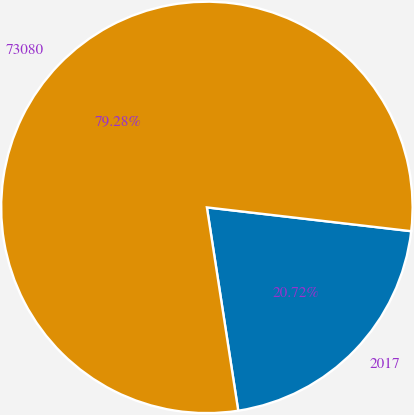Convert chart to OTSL. <chart><loc_0><loc_0><loc_500><loc_500><pie_chart><fcel>2017<fcel>73080<nl><fcel>20.72%<fcel>79.28%<nl></chart> 